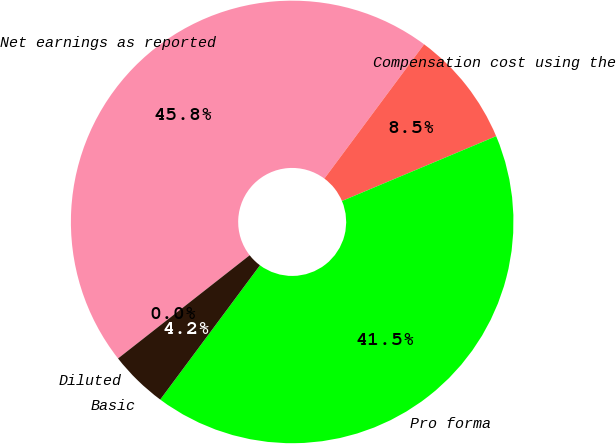Convert chart to OTSL. <chart><loc_0><loc_0><loc_500><loc_500><pie_chart><fcel>Net earnings as reported<fcel>Compensation cost using the<fcel>Pro forma<fcel>Basic<fcel>Diluted<nl><fcel>45.75%<fcel>8.5%<fcel>41.5%<fcel>4.25%<fcel>0.0%<nl></chart> 